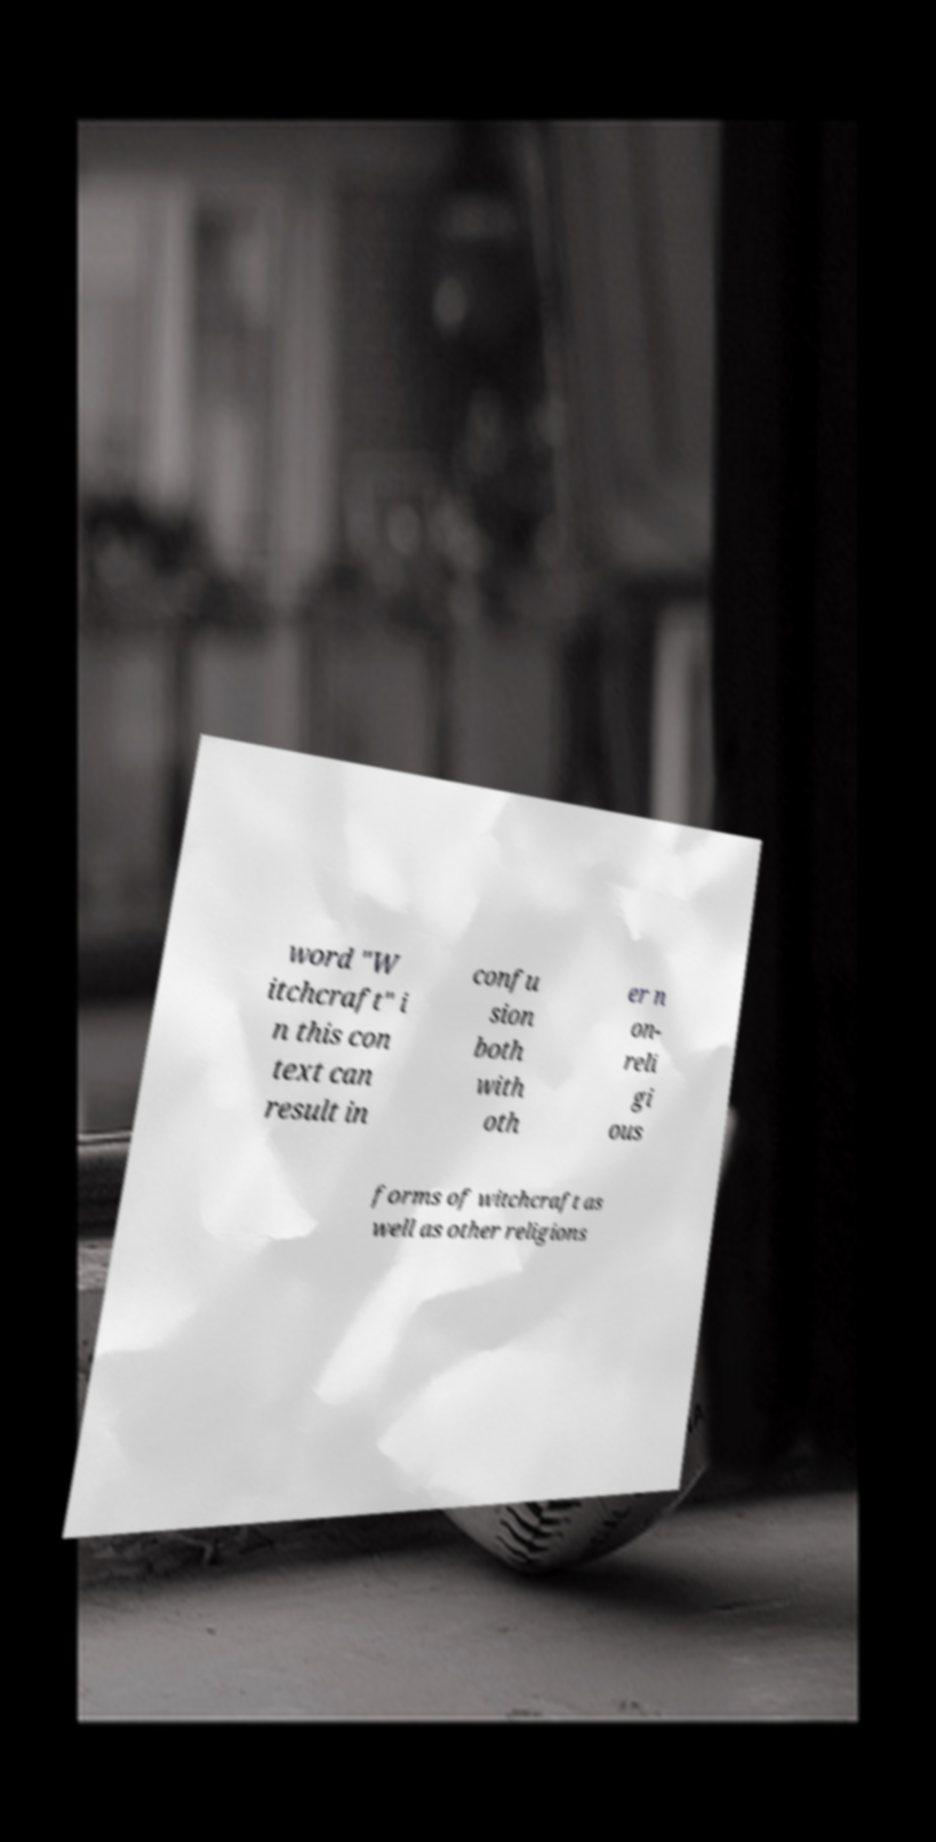Could you extract and type out the text from this image? word "W itchcraft" i n this con text can result in confu sion both with oth er n on- reli gi ous forms of witchcraft as well as other religions 